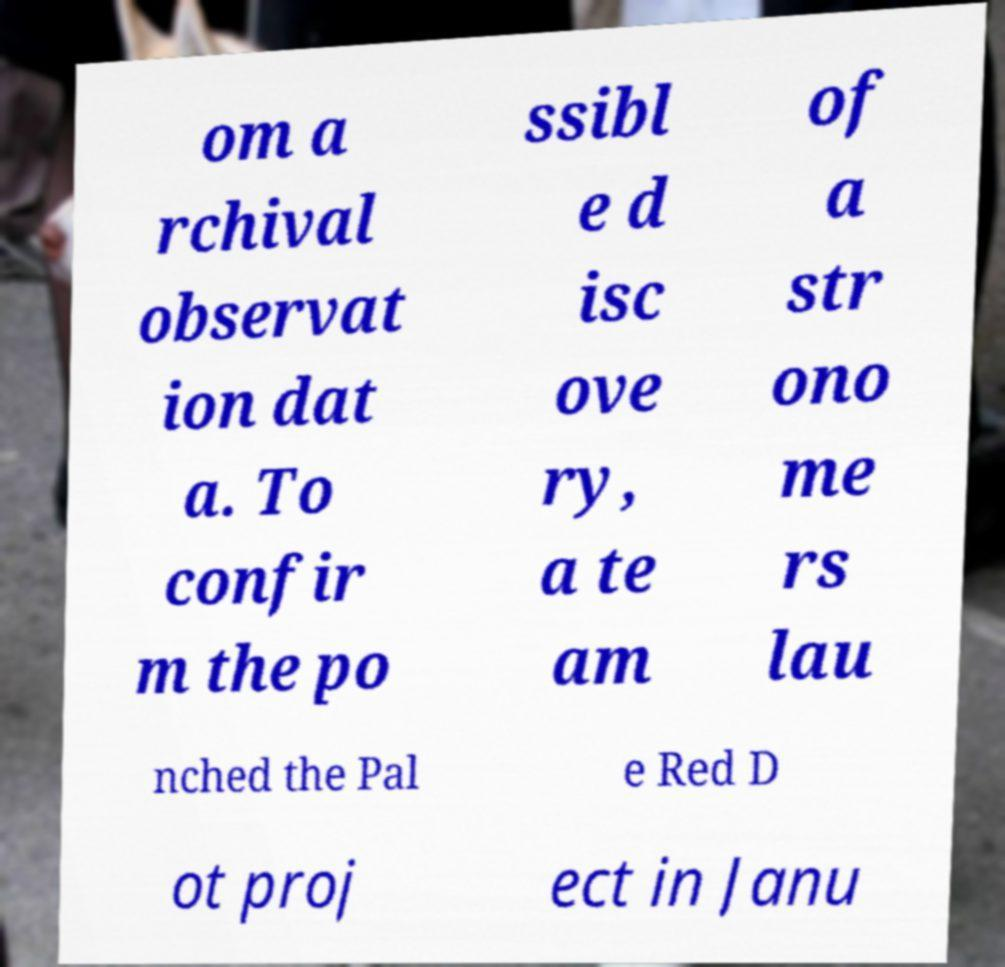Please read and relay the text visible in this image. What does it say? om a rchival observat ion dat a. To confir m the po ssibl e d isc ove ry, a te am of a str ono me rs lau nched the Pal e Red D ot proj ect in Janu 